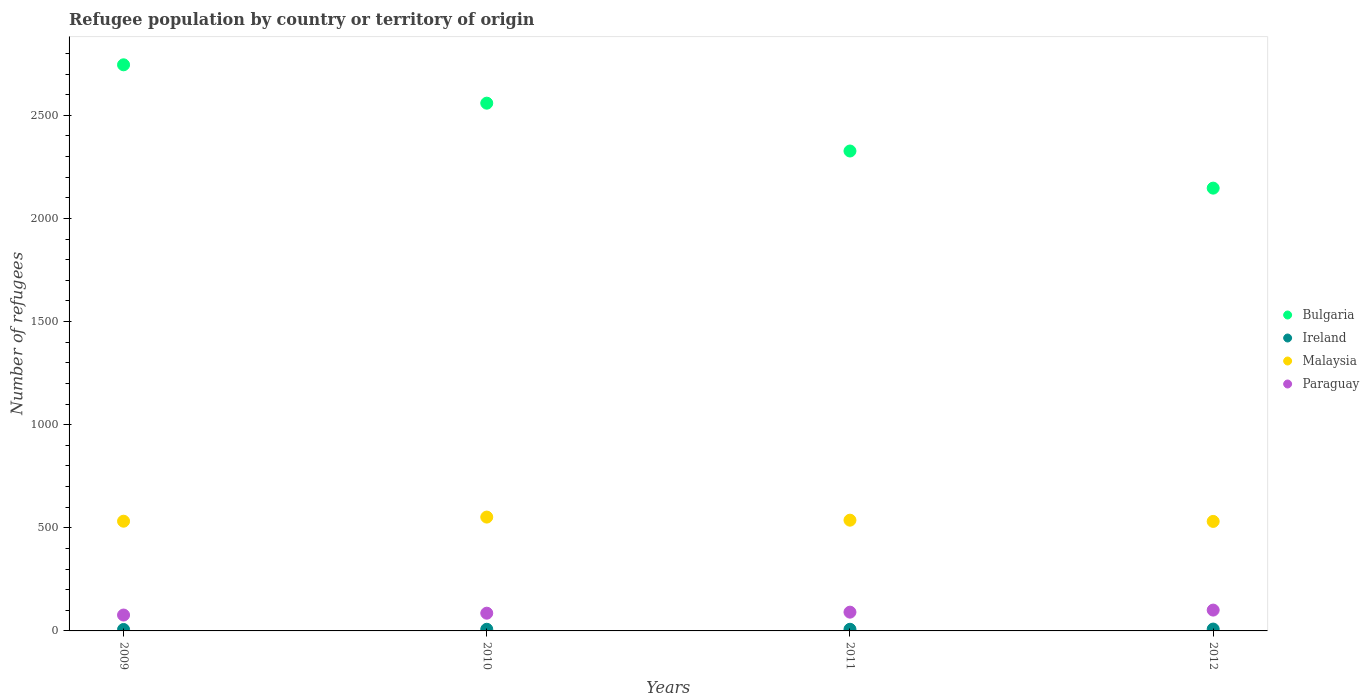What is the number of refugees in Paraguay in 2010?
Give a very brief answer. 86. Across all years, what is the maximum number of refugees in Malaysia?
Keep it short and to the point. 552. Across all years, what is the minimum number of refugees in Paraguay?
Provide a short and direct response. 77. In which year was the number of refugees in Ireland maximum?
Offer a very short reply. 2012. What is the total number of refugees in Bulgaria in the graph?
Your answer should be compact. 9778. What is the difference between the number of refugees in Malaysia in 2011 and that in 2012?
Give a very brief answer. 6. What is the difference between the number of refugees in Malaysia in 2010 and the number of refugees in Bulgaria in 2012?
Keep it short and to the point. -1595. What is the average number of refugees in Bulgaria per year?
Keep it short and to the point. 2444.5. In the year 2010, what is the difference between the number of refugees in Ireland and number of refugees in Paraguay?
Ensure brevity in your answer.  -78. What is the ratio of the number of refugees in Paraguay in 2011 to that in 2012?
Your answer should be compact. 0.9. Is the number of refugees in Ireland in 2009 less than that in 2011?
Offer a very short reply. Yes. Is the difference between the number of refugees in Ireland in 2011 and 2012 greater than the difference between the number of refugees in Paraguay in 2011 and 2012?
Make the answer very short. Yes. What is the difference between the highest and the second highest number of refugees in Malaysia?
Keep it short and to the point. 15. What is the difference between the highest and the lowest number of refugees in Malaysia?
Give a very brief answer. 21. In how many years, is the number of refugees in Bulgaria greater than the average number of refugees in Bulgaria taken over all years?
Ensure brevity in your answer.  2. Is it the case that in every year, the sum of the number of refugees in Bulgaria and number of refugees in Malaysia  is greater than the sum of number of refugees in Ireland and number of refugees in Paraguay?
Make the answer very short. Yes. Is it the case that in every year, the sum of the number of refugees in Malaysia and number of refugees in Paraguay  is greater than the number of refugees in Bulgaria?
Your answer should be compact. No. Does the number of refugees in Bulgaria monotonically increase over the years?
Offer a very short reply. No. Is the number of refugees in Ireland strictly greater than the number of refugees in Paraguay over the years?
Ensure brevity in your answer.  No. Is the number of refugees in Malaysia strictly less than the number of refugees in Paraguay over the years?
Provide a succinct answer. No. How many dotlines are there?
Provide a short and direct response. 4. How many years are there in the graph?
Ensure brevity in your answer.  4. Are the values on the major ticks of Y-axis written in scientific E-notation?
Keep it short and to the point. No. Does the graph contain any zero values?
Give a very brief answer. No. Where does the legend appear in the graph?
Provide a succinct answer. Center right. How are the legend labels stacked?
Your answer should be compact. Vertical. What is the title of the graph?
Ensure brevity in your answer.  Refugee population by country or territory of origin. Does "Ethiopia" appear as one of the legend labels in the graph?
Give a very brief answer. No. What is the label or title of the X-axis?
Make the answer very short. Years. What is the label or title of the Y-axis?
Offer a very short reply. Number of refugees. What is the Number of refugees in Bulgaria in 2009?
Ensure brevity in your answer.  2745. What is the Number of refugees in Ireland in 2009?
Give a very brief answer. 7. What is the Number of refugees in Malaysia in 2009?
Provide a succinct answer. 532. What is the Number of refugees of Bulgaria in 2010?
Provide a short and direct response. 2559. What is the Number of refugees in Malaysia in 2010?
Your answer should be very brief. 552. What is the Number of refugees in Paraguay in 2010?
Offer a very short reply. 86. What is the Number of refugees in Bulgaria in 2011?
Your answer should be very brief. 2327. What is the Number of refugees in Malaysia in 2011?
Give a very brief answer. 537. What is the Number of refugees in Paraguay in 2011?
Offer a very short reply. 91. What is the Number of refugees of Bulgaria in 2012?
Your answer should be compact. 2147. What is the Number of refugees in Malaysia in 2012?
Give a very brief answer. 531. What is the Number of refugees of Paraguay in 2012?
Provide a succinct answer. 101. Across all years, what is the maximum Number of refugees in Bulgaria?
Your answer should be very brief. 2745. Across all years, what is the maximum Number of refugees of Malaysia?
Make the answer very short. 552. Across all years, what is the maximum Number of refugees of Paraguay?
Ensure brevity in your answer.  101. Across all years, what is the minimum Number of refugees of Bulgaria?
Your response must be concise. 2147. Across all years, what is the minimum Number of refugees in Ireland?
Offer a terse response. 7. Across all years, what is the minimum Number of refugees in Malaysia?
Provide a succinct answer. 531. Across all years, what is the minimum Number of refugees in Paraguay?
Your response must be concise. 77. What is the total Number of refugees of Bulgaria in the graph?
Your answer should be very brief. 9778. What is the total Number of refugees in Malaysia in the graph?
Keep it short and to the point. 2152. What is the total Number of refugees in Paraguay in the graph?
Provide a short and direct response. 355. What is the difference between the Number of refugees of Bulgaria in 2009 and that in 2010?
Your answer should be very brief. 186. What is the difference between the Number of refugees in Ireland in 2009 and that in 2010?
Your answer should be compact. -1. What is the difference between the Number of refugees in Malaysia in 2009 and that in 2010?
Ensure brevity in your answer.  -20. What is the difference between the Number of refugees of Bulgaria in 2009 and that in 2011?
Provide a succinct answer. 418. What is the difference between the Number of refugees of Ireland in 2009 and that in 2011?
Your answer should be very brief. -1. What is the difference between the Number of refugees of Malaysia in 2009 and that in 2011?
Give a very brief answer. -5. What is the difference between the Number of refugees in Bulgaria in 2009 and that in 2012?
Ensure brevity in your answer.  598. What is the difference between the Number of refugees in Malaysia in 2009 and that in 2012?
Make the answer very short. 1. What is the difference between the Number of refugees in Paraguay in 2009 and that in 2012?
Your answer should be very brief. -24. What is the difference between the Number of refugees of Bulgaria in 2010 and that in 2011?
Make the answer very short. 232. What is the difference between the Number of refugees of Paraguay in 2010 and that in 2011?
Provide a short and direct response. -5. What is the difference between the Number of refugees of Bulgaria in 2010 and that in 2012?
Provide a succinct answer. 412. What is the difference between the Number of refugees in Malaysia in 2010 and that in 2012?
Your answer should be very brief. 21. What is the difference between the Number of refugees of Paraguay in 2010 and that in 2012?
Ensure brevity in your answer.  -15. What is the difference between the Number of refugees in Bulgaria in 2011 and that in 2012?
Provide a short and direct response. 180. What is the difference between the Number of refugees in Bulgaria in 2009 and the Number of refugees in Ireland in 2010?
Your answer should be compact. 2737. What is the difference between the Number of refugees in Bulgaria in 2009 and the Number of refugees in Malaysia in 2010?
Give a very brief answer. 2193. What is the difference between the Number of refugees in Bulgaria in 2009 and the Number of refugees in Paraguay in 2010?
Make the answer very short. 2659. What is the difference between the Number of refugees in Ireland in 2009 and the Number of refugees in Malaysia in 2010?
Give a very brief answer. -545. What is the difference between the Number of refugees of Ireland in 2009 and the Number of refugees of Paraguay in 2010?
Give a very brief answer. -79. What is the difference between the Number of refugees in Malaysia in 2009 and the Number of refugees in Paraguay in 2010?
Your answer should be compact. 446. What is the difference between the Number of refugees of Bulgaria in 2009 and the Number of refugees of Ireland in 2011?
Offer a very short reply. 2737. What is the difference between the Number of refugees in Bulgaria in 2009 and the Number of refugees in Malaysia in 2011?
Provide a short and direct response. 2208. What is the difference between the Number of refugees in Bulgaria in 2009 and the Number of refugees in Paraguay in 2011?
Your answer should be compact. 2654. What is the difference between the Number of refugees of Ireland in 2009 and the Number of refugees of Malaysia in 2011?
Ensure brevity in your answer.  -530. What is the difference between the Number of refugees of Ireland in 2009 and the Number of refugees of Paraguay in 2011?
Offer a terse response. -84. What is the difference between the Number of refugees of Malaysia in 2009 and the Number of refugees of Paraguay in 2011?
Keep it short and to the point. 441. What is the difference between the Number of refugees of Bulgaria in 2009 and the Number of refugees of Ireland in 2012?
Keep it short and to the point. 2736. What is the difference between the Number of refugees of Bulgaria in 2009 and the Number of refugees of Malaysia in 2012?
Offer a terse response. 2214. What is the difference between the Number of refugees in Bulgaria in 2009 and the Number of refugees in Paraguay in 2012?
Your answer should be very brief. 2644. What is the difference between the Number of refugees in Ireland in 2009 and the Number of refugees in Malaysia in 2012?
Give a very brief answer. -524. What is the difference between the Number of refugees in Ireland in 2009 and the Number of refugees in Paraguay in 2012?
Your response must be concise. -94. What is the difference between the Number of refugees in Malaysia in 2009 and the Number of refugees in Paraguay in 2012?
Provide a succinct answer. 431. What is the difference between the Number of refugees in Bulgaria in 2010 and the Number of refugees in Ireland in 2011?
Keep it short and to the point. 2551. What is the difference between the Number of refugees in Bulgaria in 2010 and the Number of refugees in Malaysia in 2011?
Offer a very short reply. 2022. What is the difference between the Number of refugees of Bulgaria in 2010 and the Number of refugees of Paraguay in 2011?
Your answer should be compact. 2468. What is the difference between the Number of refugees in Ireland in 2010 and the Number of refugees in Malaysia in 2011?
Give a very brief answer. -529. What is the difference between the Number of refugees of Ireland in 2010 and the Number of refugees of Paraguay in 2011?
Make the answer very short. -83. What is the difference between the Number of refugees in Malaysia in 2010 and the Number of refugees in Paraguay in 2011?
Your response must be concise. 461. What is the difference between the Number of refugees in Bulgaria in 2010 and the Number of refugees in Ireland in 2012?
Ensure brevity in your answer.  2550. What is the difference between the Number of refugees in Bulgaria in 2010 and the Number of refugees in Malaysia in 2012?
Ensure brevity in your answer.  2028. What is the difference between the Number of refugees of Bulgaria in 2010 and the Number of refugees of Paraguay in 2012?
Offer a very short reply. 2458. What is the difference between the Number of refugees in Ireland in 2010 and the Number of refugees in Malaysia in 2012?
Your answer should be very brief. -523. What is the difference between the Number of refugees in Ireland in 2010 and the Number of refugees in Paraguay in 2012?
Keep it short and to the point. -93. What is the difference between the Number of refugees of Malaysia in 2010 and the Number of refugees of Paraguay in 2012?
Your answer should be compact. 451. What is the difference between the Number of refugees in Bulgaria in 2011 and the Number of refugees in Ireland in 2012?
Ensure brevity in your answer.  2318. What is the difference between the Number of refugees of Bulgaria in 2011 and the Number of refugees of Malaysia in 2012?
Ensure brevity in your answer.  1796. What is the difference between the Number of refugees in Bulgaria in 2011 and the Number of refugees in Paraguay in 2012?
Your answer should be very brief. 2226. What is the difference between the Number of refugees of Ireland in 2011 and the Number of refugees of Malaysia in 2012?
Your answer should be very brief. -523. What is the difference between the Number of refugees of Ireland in 2011 and the Number of refugees of Paraguay in 2012?
Ensure brevity in your answer.  -93. What is the difference between the Number of refugees of Malaysia in 2011 and the Number of refugees of Paraguay in 2012?
Your response must be concise. 436. What is the average Number of refugees of Bulgaria per year?
Make the answer very short. 2444.5. What is the average Number of refugees of Ireland per year?
Your answer should be very brief. 8. What is the average Number of refugees of Malaysia per year?
Make the answer very short. 538. What is the average Number of refugees of Paraguay per year?
Ensure brevity in your answer.  88.75. In the year 2009, what is the difference between the Number of refugees in Bulgaria and Number of refugees in Ireland?
Offer a terse response. 2738. In the year 2009, what is the difference between the Number of refugees of Bulgaria and Number of refugees of Malaysia?
Offer a terse response. 2213. In the year 2009, what is the difference between the Number of refugees of Bulgaria and Number of refugees of Paraguay?
Offer a very short reply. 2668. In the year 2009, what is the difference between the Number of refugees in Ireland and Number of refugees in Malaysia?
Give a very brief answer. -525. In the year 2009, what is the difference between the Number of refugees in Ireland and Number of refugees in Paraguay?
Provide a succinct answer. -70. In the year 2009, what is the difference between the Number of refugees in Malaysia and Number of refugees in Paraguay?
Make the answer very short. 455. In the year 2010, what is the difference between the Number of refugees in Bulgaria and Number of refugees in Ireland?
Make the answer very short. 2551. In the year 2010, what is the difference between the Number of refugees of Bulgaria and Number of refugees of Malaysia?
Your answer should be very brief. 2007. In the year 2010, what is the difference between the Number of refugees of Bulgaria and Number of refugees of Paraguay?
Your response must be concise. 2473. In the year 2010, what is the difference between the Number of refugees in Ireland and Number of refugees in Malaysia?
Provide a succinct answer. -544. In the year 2010, what is the difference between the Number of refugees in Ireland and Number of refugees in Paraguay?
Provide a short and direct response. -78. In the year 2010, what is the difference between the Number of refugees of Malaysia and Number of refugees of Paraguay?
Your answer should be very brief. 466. In the year 2011, what is the difference between the Number of refugees of Bulgaria and Number of refugees of Ireland?
Your response must be concise. 2319. In the year 2011, what is the difference between the Number of refugees of Bulgaria and Number of refugees of Malaysia?
Make the answer very short. 1790. In the year 2011, what is the difference between the Number of refugees in Bulgaria and Number of refugees in Paraguay?
Your answer should be compact. 2236. In the year 2011, what is the difference between the Number of refugees of Ireland and Number of refugees of Malaysia?
Provide a succinct answer. -529. In the year 2011, what is the difference between the Number of refugees of Ireland and Number of refugees of Paraguay?
Make the answer very short. -83. In the year 2011, what is the difference between the Number of refugees of Malaysia and Number of refugees of Paraguay?
Your answer should be compact. 446. In the year 2012, what is the difference between the Number of refugees of Bulgaria and Number of refugees of Ireland?
Give a very brief answer. 2138. In the year 2012, what is the difference between the Number of refugees in Bulgaria and Number of refugees in Malaysia?
Offer a terse response. 1616. In the year 2012, what is the difference between the Number of refugees in Bulgaria and Number of refugees in Paraguay?
Provide a succinct answer. 2046. In the year 2012, what is the difference between the Number of refugees in Ireland and Number of refugees in Malaysia?
Make the answer very short. -522. In the year 2012, what is the difference between the Number of refugees in Ireland and Number of refugees in Paraguay?
Your response must be concise. -92. In the year 2012, what is the difference between the Number of refugees of Malaysia and Number of refugees of Paraguay?
Offer a terse response. 430. What is the ratio of the Number of refugees of Bulgaria in 2009 to that in 2010?
Give a very brief answer. 1.07. What is the ratio of the Number of refugees in Ireland in 2009 to that in 2010?
Your response must be concise. 0.88. What is the ratio of the Number of refugees in Malaysia in 2009 to that in 2010?
Provide a succinct answer. 0.96. What is the ratio of the Number of refugees in Paraguay in 2009 to that in 2010?
Offer a very short reply. 0.9. What is the ratio of the Number of refugees of Bulgaria in 2009 to that in 2011?
Give a very brief answer. 1.18. What is the ratio of the Number of refugees of Ireland in 2009 to that in 2011?
Your answer should be very brief. 0.88. What is the ratio of the Number of refugees in Malaysia in 2009 to that in 2011?
Offer a very short reply. 0.99. What is the ratio of the Number of refugees of Paraguay in 2009 to that in 2011?
Your response must be concise. 0.85. What is the ratio of the Number of refugees in Bulgaria in 2009 to that in 2012?
Make the answer very short. 1.28. What is the ratio of the Number of refugees of Paraguay in 2009 to that in 2012?
Make the answer very short. 0.76. What is the ratio of the Number of refugees in Bulgaria in 2010 to that in 2011?
Provide a short and direct response. 1.1. What is the ratio of the Number of refugees of Malaysia in 2010 to that in 2011?
Keep it short and to the point. 1.03. What is the ratio of the Number of refugees of Paraguay in 2010 to that in 2011?
Make the answer very short. 0.95. What is the ratio of the Number of refugees of Bulgaria in 2010 to that in 2012?
Make the answer very short. 1.19. What is the ratio of the Number of refugees in Malaysia in 2010 to that in 2012?
Your answer should be very brief. 1.04. What is the ratio of the Number of refugees in Paraguay in 2010 to that in 2012?
Your answer should be very brief. 0.85. What is the ratio of the Number of refugees in Bulgaria in 2011 to that in 2012?
Give a very brief answer. 1.08. What is the ratio of the Number of refugees in Ireland in 2011 to that in 2012?
Keep it short and to the point. 0.89. What is the ratio of the Number of refugees of Malaysia in 2011 to that in 2012?
Provide a succinct answer. 1.01. What is the ratio of the Number of refugees in Paraguay in 2011 to that in 2012?
Ensure brevity in your answer.  0.9. What is the difference between the highest and the second highest Number of refugees in Bulgaria?
Provide a succinct answer. 186. What is the difference between the highest and the second highest Number of refugees in Ireland?
Offer a terse response. 1. What is the difference between the highest and the second highest Number of refugees in Paraguay?
Provide a succinct answer. 10. What is the difference between the highest and the lowest Number of refugees in Bulgaria?
Provide a short and direct response. 598. What is the difference between the highest and the lowest Number of refugees of Paraguay?
Make the answer very short. 24. 